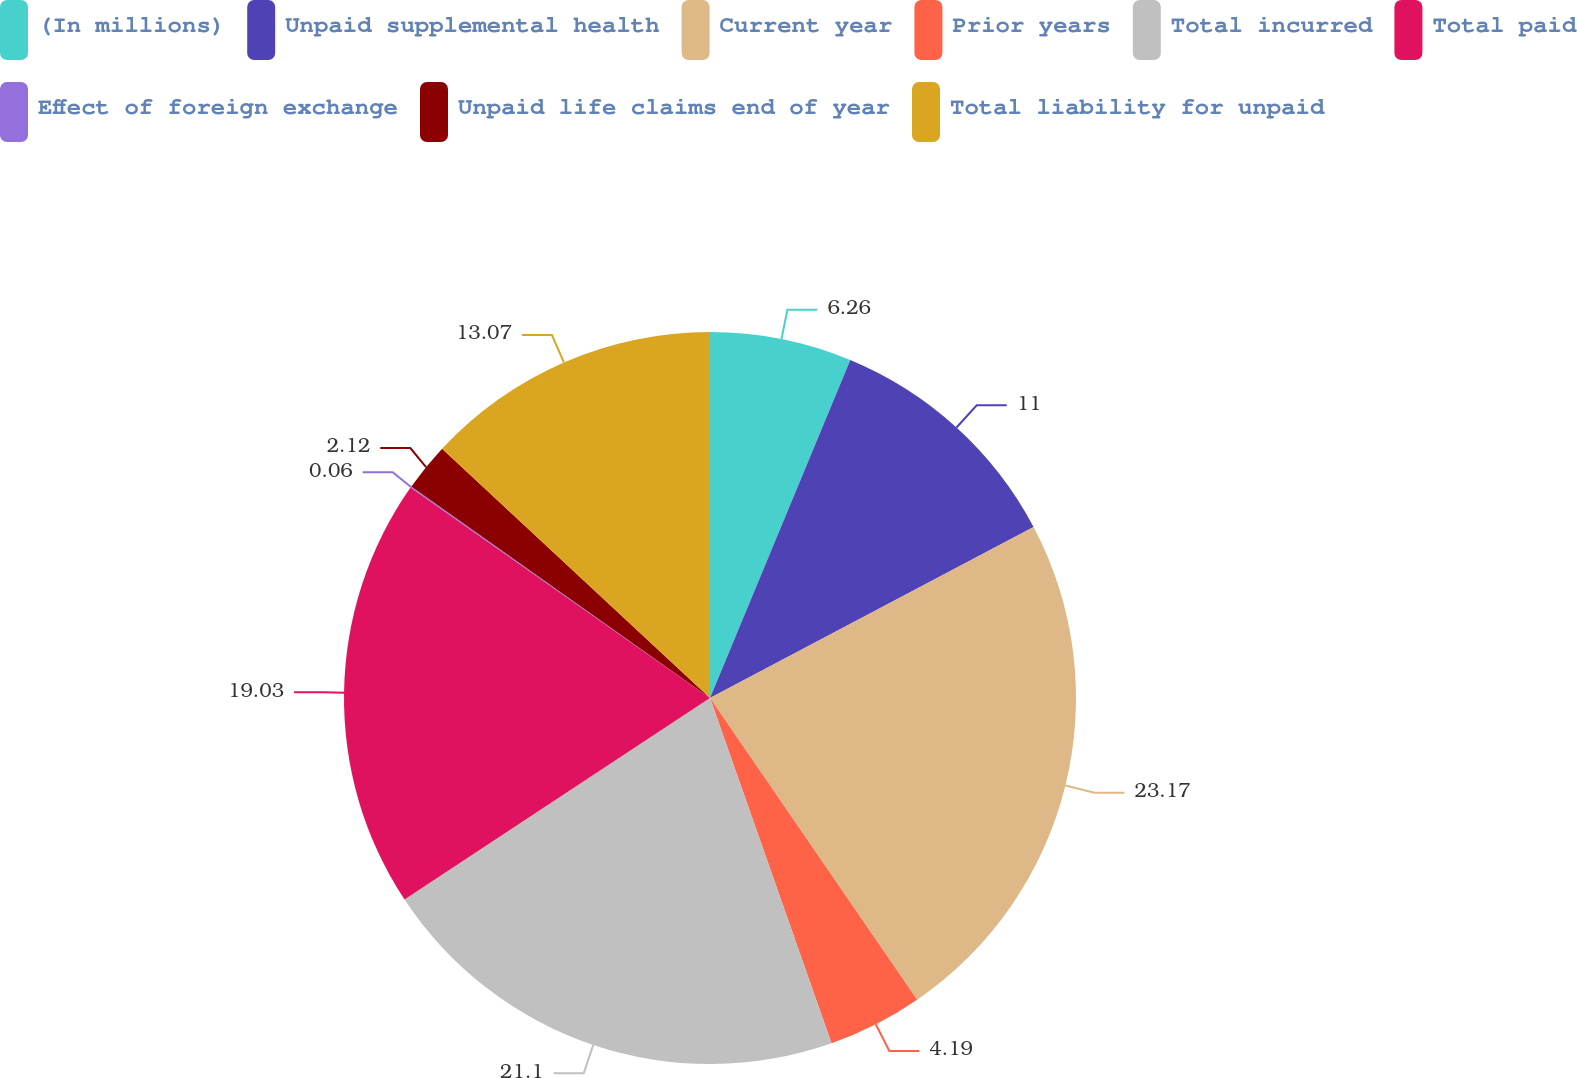Convert chart to OTSL. <chart><loc_0><loc_0><loc_500><loc_500><pie_chart><fcel>(In millions)<fcel>Unpaid supplemental health<fcel>Current year<fcel>Prior years<fcel>Total incurred<fcel>Total paid<fcel>Effect of foreign exchange<fcel>Unpaid life claims end of year<fcel>Total liability for unpaid<nl><fcel>6.26%<fcel>11.0%<fcel>23.16%<fcel>4.19%<fcel>21.1%<fcel>19.03%<fcel>0.06%<fcel>2.12%<fcel>13.07%<nl></chart> 